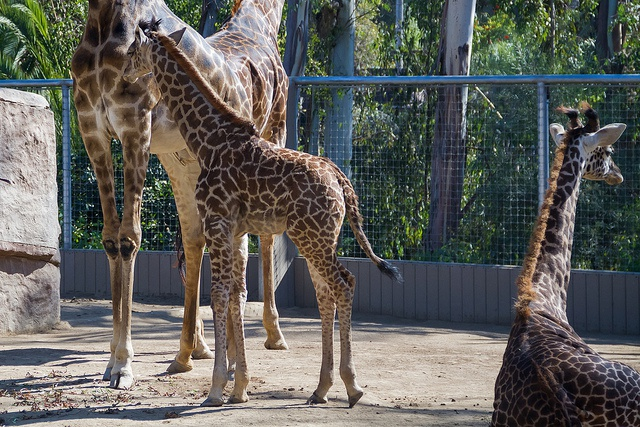Describe the objects in this image and their specific colors. I can see giraffe in olive, black, and gray tones, giraffe in olive, gray, black, and maroon tones, giraffe in olive, black, gray, and darkgray tones, and giraffe in olive, lightgray, darkgray, gray, and brown tones in this image. 